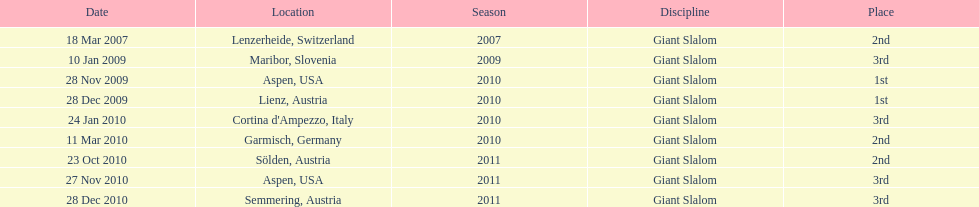Where was her first win? Aspen, USA. 